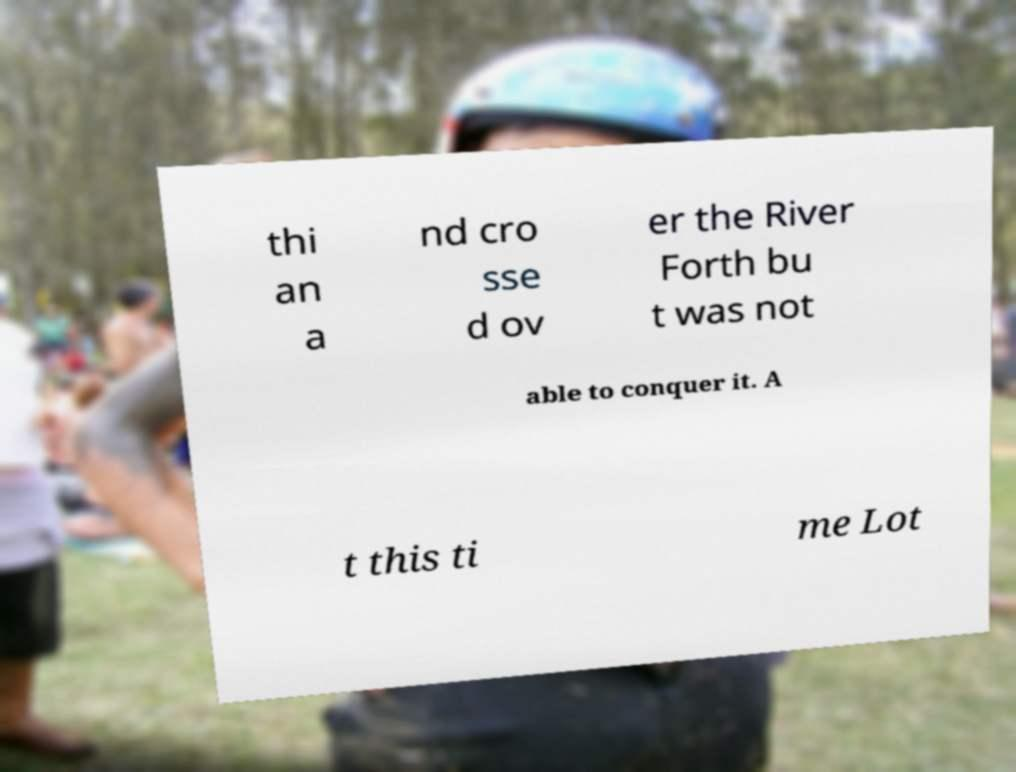Please read and relay the text visible in this image. What does it say? thi an a nd cro sse d ov er the River Forth bu t was not able to conquer it. A t this ti me Lot 